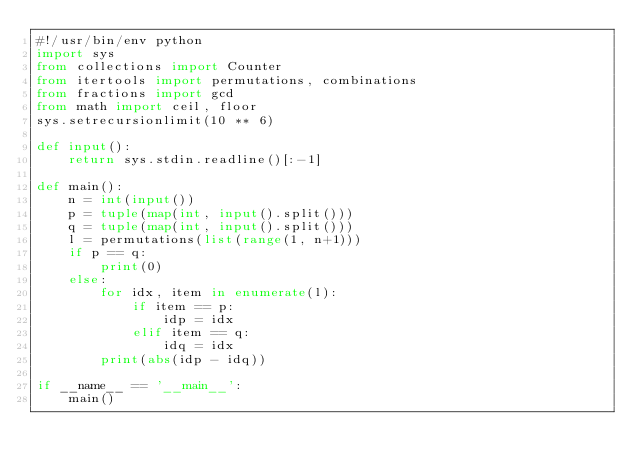Convert code to text. <code><loc_0><loc_0><loc_500><loc_500><_Python_>#!/usr/bin/env python
import sys
from collections import Counter
from itertools import permutations, combinations
from fractions import gcd
from math import ceil, floor
sys.setrecursionlimit(10 ** 6)

def input():
    return sys.stdin.readline()[:-1]

def main():
    n = int(input())
    p = tuple(map(int, input().split()))
    q = tuple(map(int, input().split()))
    l = permutations(list(range(1, n+1)))
    if p == q:
        print(0)
    else:
        for idx, item in enumerate(l):
            if item == p:
                idp = idx
            elif item == q:
                idq = idx
        print(abs(idp - idq))

if __name__ == '__main__':
    main()</code> 